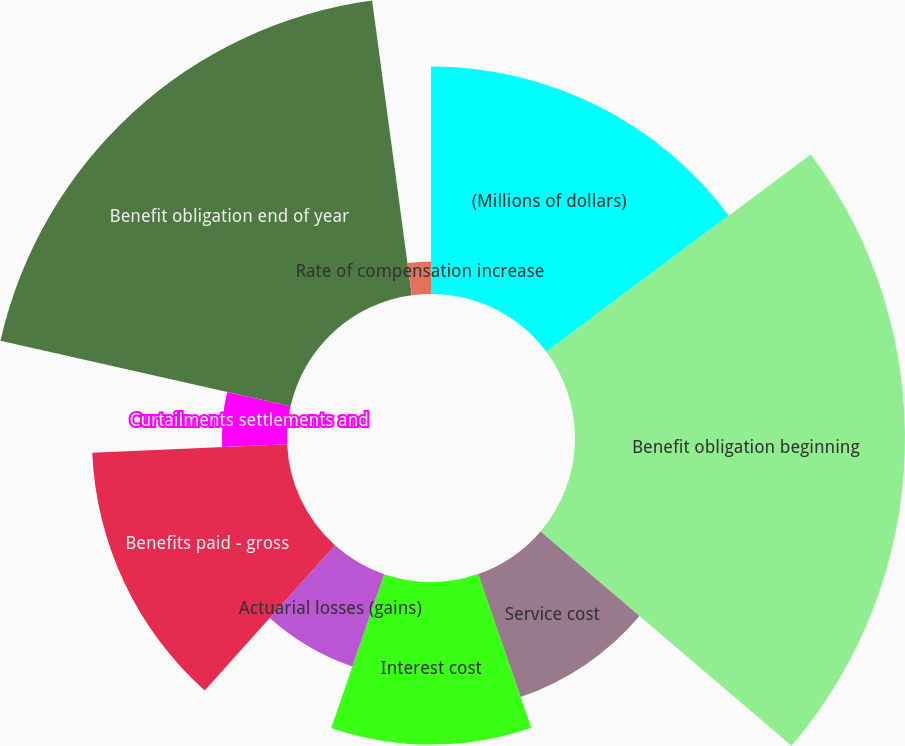Convert chart to OTSL. <chart><loc_0><loc_0><loc_500><loc_500><pie_chart><fcel>(Millions of dollars)<fcel>Benefit obligation beginning<fcel>Service cost<fcel>Interest cost<fcel>Actuarial losses (gains)<fcel>Benefits paid - gross<fcel>Curtailments settlements and<fcel>Benefit obligation end of year<fcel>Discount rate<fcel>Rate of compensation increase<nl><fcel>14.79%<fcel>21.45%<fcel>8.46%<fcel>10.57%<fcel>6.35%<fcel>12.68%<fcel>4.23%<fcel>19.33%<fcel>0.01%<fcel>2.12%<nl></chart> 